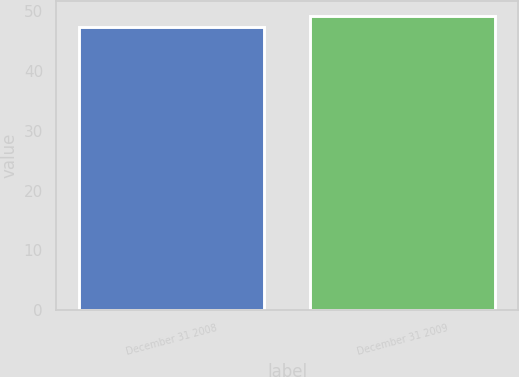<chart> <loc_0><loc_0><loc_500><loc_500><bar_chart><fcel>December 31 2008<fcel>December 31 2009<nl><fcel>47.39<fcel>49.16<nl></chart> 